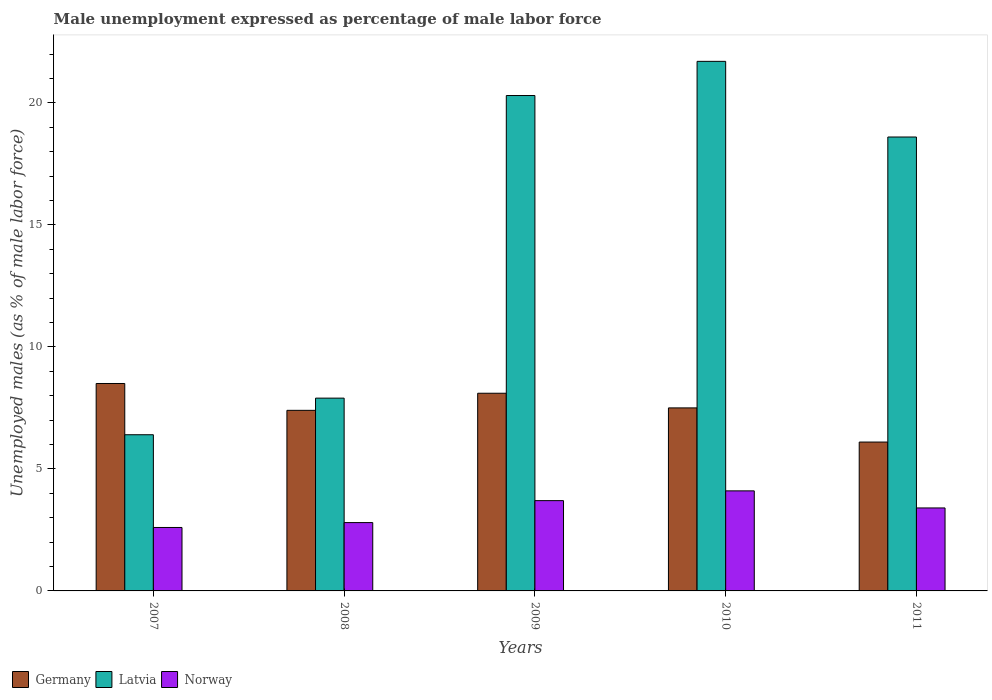How many different coloured bars are there?
Give a very brief answer. 3. How many groups of bars are there?
Your response must be concise. 5. Are the number of bars per tick equal to the number of legend labels?
Your answer should be very brief. Yes. Are the number of bars on each tick of the X-axis equal?
Your answer should be compact. Yes. How many bars are there on the 2nd tick from the left?
Offer a terse response. 3. How many bars are there on the 3rd tick from the right?
Your response must be concise. 3. In how many cases, is the number of bars for a given year not equal to the number of legend labels?
Offer a terse response. 0. What is the unemployment in males in in Germany in 2009?
Keep it short and to the point. 8.1. Across all years, what is the minimum unemployment in males in in Germany?
Your response must be concise. 6.1. What is the total unemployment in males in in Norway in the graph?
Offer a very short reply. 16.6. What is the difference between the unemployment in males in in Latvia in 2007 and that in 2011?
Your response must be concise. -12.2. What is the difference between the unemployment in males in in Latvia in 2010 and the unemployment in males in in Norway in 2009?
Your response must be concise. 18. What is the average unemployment in males in in Norway per year?
Offer a very short reply. 3.32. What is the ratio of the unemployment in males in in Germany in 2009 to that in 2010?
Your answer should be very brief. 1.08. Is the difference between the unemployment in males in in Latvia in 2008 and 2010 greater than the difference between the unemployment in males in in Germany in 2008 and 2010?
Make the answer very short. No. What is the difference between the highest and the second highest unemployment in males in in Germany?
Your answer should be compact. 0.4. What is the difference between the highest and the lowest unemployment in males in in Latvia?
Offer a terse response. 15.3. In how many years, is the unemployment in males in in Norway greater than the average unemployment in males in in Norway taken over all years?
Provide a succinct answer. 3. Is the sum of the unemployment in males in in Norway in 2007 and 2009 greater than the maximum unemployment in males in in Germany across all years?
Your answer should be compact. No. What does the 2nd bar from the left in 2010 represents?
Your answer should be compact. Latvia. What does the 1st bar from the right in 2009 represents?
Provide a succinct answer. Norway. Is it the case that in every year, the sum of the unemployment in males in in Germany and unemployment in males in in Norway is greater than the unemployment in males in in Latvia?
Keep it short and to the point. No. How many bars are there?
Offer a terse response. 15. How many years are there in the graph?
Provide a succinct answer. 5. Are the values on the major ticks of Y-axis written in scientific E-notation?
Give a very brief answer. No. Does the graph contain any zero values?
Your response must be concise. No. What is the title of the graph?
Provide a short and direct response. Male unemployment expressed as percentage of male labor force. What is the label or title of the X-axis?
Give a very brief answer. Years. What is the label or title of the Y-axis?
Your response must be concise. Unemployed males (as % of male labor force). What is the Unemployed males (as % of male labor force) in Latvia in 2007?
Make the answer very short. 6.4. What is the Unemployed males (as % of male labor force) in Norway in 2007?
Give a very brief answer. 2.6. What is the Unemployed males (as % of male labor force) of Germany in 2008?
Keep it short and to the point. 7.4. What is the Unemployed males (as % of male labor force) of Latvia in 2008?
Make the answer very short. 7.9. What is the Unemployed males (as % of male labor force) in Norway in 2008?
Provide a succinct answer. 2.8. What is the Unemployed males (as % of male labor force) in Germany in 2009?
Your answer should be very brief. 8.1. What is the Unemployed males (as % of male labor force) of Latvia in 2009?
Your answer should be compact. 20.3. What is the Unemployed males (as % of male labor force) of Norway in 2009?
Keep it short and to the point. 3.7. What is the Unemployed males (as % of male labor force) in Latvia in 2010?
Your answer should be very brief. 21.7. What is the Unemployed males (as % of male labor force) in Norway in 2010?
Make the answer very short. 4.1. What is the Unemployed males (as % of male labor force) in Germany in 2011?
Give a very brief answer. 6.1. What is the Unemployed males (as % of male labor force) of Latvia in 2011?
Offer a terse response. 18.6. What is the Unemployed males (as % of male labor force) of Norway in 2011?
Offer a very short reply. 3.4. Across all years, what is the maximum Unemployed males (as % of male labor force) in Latvia?
Provide a short and direct response. 21.7. Across all years, what is the maximum Unemployed males (as % of male labor force) of Norway?
Ensure brevity in your answer.  4.1. Across all years, what is the minimum Unemployed males (as % of male labor force) in Germany?
Provide a short and direct response. 6.1. Across all years, what is the minimum Unemployed males (as % of male labor force) in Latvia?
Your answer should be very brief. 6.4. Across all years, what is the minimum Unemployed males (as % of male labor force) in Norway?
Make the answer very short. 2.6. What is the total Unemployed males (as % of male labor force) in Germany in the graph?
Ensure brevity in your answer.  37.6. What is the total Unemployed males (as % of male labor force) of Latvia in the graph?
Ensure brevity in your answer.  74.9. What is the difference between the Unemployed males (as % of male labor force) in Germany in 2007 and that in 2008?
Your answer should be compact. 1.1. What is the difference between the Unemployed males (as % of male labor force) in Norway in 2007 and that in 2008?
Make the answer very short. -0.2. What is the difference between the Unemployed males (as % of male labor force) of Latvia in 2007 and that in 2009?
Keep it short and to the point. -13.9. What is the difference between the Unemployed males (as % of male labor force) in Latvia in 2007 and that in 2010?
Provide a short and direct response. -15.3. What is the difference between the Unemployed males (as % of male labor force) in Norway in 2007 and that in 2010?
Keep it short and to the point. -1.5. What is the difference between the Unemployed males (as % of male labor force) in Germany in 2007 and that in 2011?
Keep it short and to the point. 2.4. What is the difference between the Unemployed males (as % of male labor force) of Norway in 2007 and that in 2011?
Your response must be concise. -0.8. What is the difference between the Unemployed males (as % of male labor force) in Germany in 2008 and that in 2009?
Offer a very short reply. -0.7. What is the difference between the Unemployed males (as % of male labor force) of Latvia in 2008 and that in 2009?
Keep it short and to the point. -12.4. What is the difference between the Unemployed males (as % of male labor force) of Norway in 2008 and that in 2009?
Your answer should be very brief. -0.9. What is the difference between the Unemployed males (as % of male labor force) of Latvia in 2008 and that in 2010?
Offer a terse response. -13.8. What is the difference between the Unemployed males (as % of male labor force) in Germany in 2008 and that in 2011?
Provide a succinct answer. 1.3. What is the difference between the Unemployed males (as % of male labor force) in Latvia in 2008 and that in 2011?
Offer a very short reply. -10.7. What is the difference between the Unemployed males (as % of male labor force) of Norway in 2008 and that in 2011?
Keep it short and to the point. -0.6. What is the difference between the Unemployed males (as % of male labor force) in Latvia in 2009 and that in 2010?
Offer a terse response. -1.4. What is the difference between the Unemployed males (as % of male labor force) in Norway in 2009 and that in 2010?
Your answer should be very brief. -0.4. What is the difference between the Unemployed males (as % of male labor force) in Germany in 2009 and that in 2011?
Provide a short and direct response. 2. What is the difference between the Unemployed males (as % of male labor force) of Latvia in 2009 and that in 2011?
Ensure brevity in your answer.  1.7. What is the difference between the Unemployed males (as % of male labor force) in Norway in 2009 and that in 2011?
Ensure brevity in your answer.  0.3. What is the difference between the Unemployed males (as % of male labor force) of Latvia in 2010 and that in 2011?
Give a very brief answer. 3.1. What is the difference between the Unemployed males (as % of male labor force) in Norway in 2010 and that in 2011?
Make the answer very short. 0.7. What is the difference between the Unemployed males (as % of male labor force) in Germany in 2007 and the Unemployed males (as % of male labor force) in Latvia in 2009?
Offer a very short reply. -11.8. What is the difference between the Unemployed males (as % of male labor force) in Germany in 2007 and the Unemployed males (as % of male labor force) in Latvia in 2010?
Offer a terse response. -13.2. What is the difference between the Unemployed males (as % of male labor force) in Germany in 2007 and the Unemployed males (as % of male labor force) in Norway in 2010?
Offer a very short reply. 4.4. What is the difference between the Unemployed males (as % of male labor force) in Germany in 2007 and the Unemployed males (as % of male labor force) in Latvia in 2011?
Offer a terse response. -10.1. What is the difference between the Unemployed males (as % of male labor force) in Germany in 2007 and the Unemployed males (as % of male labor force) in Norway in 2011?
Your answer should be very brief. 5.1. What is the difference between the Unemployed males (as % of male labor force) of Latvia in 2007 and the Unemployed males (as % of male labor force) of Norway in 2011?
Your answer should be compact. 3. What is the difference between the Unemployed males (as % of male labor force) in Germany in 2008 and the Unemployed males (as % of male labor force) in Latvia in 2009?
Ensure brevity in your answer.  -12.9. What is the difference between the Unemployed males (as % of male labor force) in Germany in 2008 and the Unemployed males (as % of male labor force) in Latvia in 2010?
Your response must be concise. -14.3. What is the difference between the Unemployed males (as % of male labor force) in Germany in 2008 and the Unemployed males (as % of male labor force) in Norway in 2010?
Provide a succinct answer. 3.3. What is the difference between the Unemployed males (as % of male labor force) of Latvia in 2008 and the Unemployed males (as % of male labor force) of Norway in 2010?
Offer a terse response. 3.8. What is the difference between the Unemployed males (as % of male labor force) of Germany in 2008 and the Unemployed males (as % of male labor force) of Norway in 2011?
Make the answer very short. 4. What is the difference between the Unemployed males (as % of male labor force) of Latvia in 2008 and the Unemployed males (as % of male labor force) of Norway in 2011?
Your answer should be very brief. 4.5. What is the difference between the Unemployed males (as % of male labor force) in Germany in 2009 and the Unemployed males (as % of male labor force) in Norway in 2010?
Ensure brevity in your answer.  4. What is the difference between the Unemployed males (as % of male labor force) of Latvia in 2009 and the Unemployed males (as % of male labor force) of Norway in 2010?
Make the answer very short. 16.2. What is the difference between the Unemployed males (as % of male labor force) in Germany in 2009 and the Unemployed males (as % of male labor force) in Norway in 2011?
Your answer should be compact. 4.7. What is the difference between the Unemployed males (as % of male labor force) in Latvia in 2009 and the Unemployed males (as % of male labor force) in Norway in 2011?
Ensure brevity in your answer.  16.9. What is the difference between the Unemployed males (as % of male labor force) in Germany in 2010 and the Unemployed males (as % of male labor force) in Latvia in 2011?
Provide a short and direct response. -11.1. What is the average Unemployed males (as % of male labor force) of Germany per year?
Give a very brief answer. 7.52. What is the average Unemployed males (as % of male labor force) of Latvia per year?
Offer a very short reply. 14.98. What is the average Unemployed males (as % of male labor force) in Norway per year?
Ensure brevity in your answer.  3.32. In the year 2007, what is the difference between the Unemployed males (as % of male labor force) of Germany and Unemployed males (as % of male labor force) of Latvia?
Keep it short and to the point. 2.1. In the year 2007, what is the difference between the Unemployed males (as % of male labor force) of Germany and Unemployed males (as % of male labor force) of Norway?
Your response must be concise. 5.9. In the year 2007, what is the difference between the Unemployed males (as % of male labor force) in Latvia and Unemployed males (as % of male labor force) in Norway?
Keep it short and to the point. 3.8. In the year 2008, what is the difference between the Unemployed males (as % of male labor force) of Germany and Unemployed males (as % of male labor force) of Norway?
Give a very brief answer. 4.6. In the year 2008, what is the difference between the Unemployed males (as % of male labor force) of Latvia and Unemployed males (as % of male labor force) of Norway?
Your answer should be compact. 5.1. In the year 2009, what is the difference between the Unemployed males (as % of male labor force) of Germany and Unemployed males (as % of male labor force) of Latvia?
Give a very brief answer. -12.2. In the year 2009, what is the difference between the Unemployed males (as % of male labor force) of Germany and Unemployed males (as % of male labor force) of Norway?
Provide a short and direct response. 4.4. In the year 2009, what is the difference between the Unemployed males (as % of male labor force) of Latvia and Unemployed males (as % of male labor force) of Norway?
Your response must be concise. 16.6. In the year 2010, what is the difference between the Unemployed males (as % of male labor force) of Latvia and Unemployed males (as % of male labor force) of Norway?
Your answer should be very brief. 17.6. In the year 2011, what is the difference between the Unemployed males (as % of male labor force) of Germany and Unemployed males (as % of male labor force) of Latvia?
Your answer should be compact. -12.5. What is the ratio of the Unemployed males (as % of male labor force) in Germany in 2007 to that in 2008?
Keep it short and to the point. 1.15. What is the ratio of the Unemployed males (as % of male labor force) in Latvia in 2007 to that in 2008?
Provide a short and direct response. 0.81. What is the ratio of the Unemployed males (as % of male labor force) in Norway in 2007 to that in 2008?
Keep it short and to the point. 0.93. What is the ratio of the Unemployed males (as % of male labor force) of Germany in 2007 to that in 2009?
Your answer should be very brief. 1.05. What is the ratio of the Unemployed males (as % of male labor force) in Latvia in 2007 to that in 2009?
Your answer should be very brief. 0.32. What is the ratio of the Unemployed males (as % of male labor force) of Norway in 2007 to that in 2009?
Offer a terse response. 0.7. What is the ratio of the Unemployed males (as % of male labor force) in Germany in 2007 to that in 2010?
Give a very brief answer. 1.13. What is the ratio of the Unemployed males (as % of male labor force) of Latvia in 2007 to that in 2010?
Provide a succinct answer. 0.29. What is the ratio of the Unemployed males (as % of male labor force) in Norway in 2007 to that in 2010?
Offer a very short reply. 0.63. What is the ratio of the Unemployed males (as % of male labor force) of Germany in 2007 to that in 2011?
Offer a very short reply. 1.39. What is the ratio of the Unemployed males (as % of male labor force) of Latvia in 2007 to that in 2011?
Provide a succinct answer. 0.34. What is the ratio of the Unemployed males (as % of male labor force) of Norway in 2007 to that in 2011?
Your response must be concise. 0.76. What is the ratio of the Unemployed males (as % of male labor force) in Germany in 2008 to that in 2009?
Offer a very short reply. 0.91. What is the ratio of the Unemployed males (as % of male labor force) in Latvia in 2008 to that in 2009?
Offer a terse response. 0.39. What is the ratio of the Unemployed males (as % of male labor force) in Norway in 2008 to that in 2009?
Your answer should be compact. 0.76. What is the ratio of the Unemployed males (as % of male labor force) in Germany in 2008 to that in 2010?
Offer a very short reply. 0.99. What is the ratio of the Unemployed males (as % of male labor force) in Latvia in 2008 to that in 2010?
Make the answer very short. 0.36. What is the ratio of the Unemployed males (as % of male labor force) in Norway in 2008 to that in 2010?
Your answer should be compact. 0.68. What is the ratio of the Unemployed males (as % of male labor force) of Germany in 2008 to that in 2011?
Your response must be concise. 1.21. What is the ratio of the Unemployed males (as % of male labor force) in Latvia in 2008 to that in 2011?
Your answer should be compact. 0.42. What is the ratio of the Unemployed males (as % of male labor force) of Norway in 2008 to that in 2011?
Your answer should be compact. 0.82. What is the ratio of the Unemployed males (as % of male labor force) in Germany in 2009 to that in 2010?
Your answer should be compact. 1.08. What is the ratio of the Unemployed males (as % of male labor force) of Latvia in 2009 to that in 2010?
Your response must be concise. 0.94. What is the ratio of the Unemployed males (as % of male labor force) of Norway in 2009 to that in 2010?
Offer a terse response. 0.9. What is the ratio of the Unemployed males (as % of male labor force) of Germany in 2009 to that in 2011?
Your answer should be compact. 1.33. What is the ratio of the Unemployed males (as % of male labor force) in Latvia in 2009 to that in 2011?
Keep it short and to the point. 1.09. What is the ratio of the Unemployed males (as % of male labor force) of Norway in 2009 to that in 2011?
Offer a terse response. 1.09. What is the ratio of the Unemployed males (as % of male labor force) in Germany in 2010 to that in 2011?
Provide a short and direct response. 1.23. What is the ratio of the Unemployed males (as % of male labor force) of Latvia in 2010 to that in 2011?
Offer a terse response. 1.17. What is the ratio of the Unemployed males (as % of male labor force) in Norway in 2010 to that in 2011?
Provide a succinct answer. 1.21. What is the difference between the highest and the second highest Unemployed males (as % of male labor force) of Latvia?
Provide a succinct answer. 1.4. What is the difference between the highest and the second highest Unemployed males (as % of male labor force) in Norway?
Your response must be concise. 0.4. What is the difference between the highest and the lowest Unemployed males (as % of male labor force) in Germany?
Your answer should be very brief. 2.4. What is the difference between the highest and the lowest Unemployed males (as % of male labor force) of Norway?
Offer a terse response. 1.5. 